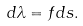Convert formula to latex. <formula><loc_0><loc_0><loc_500><loc_500>d \lambda = f d s .</formula> 